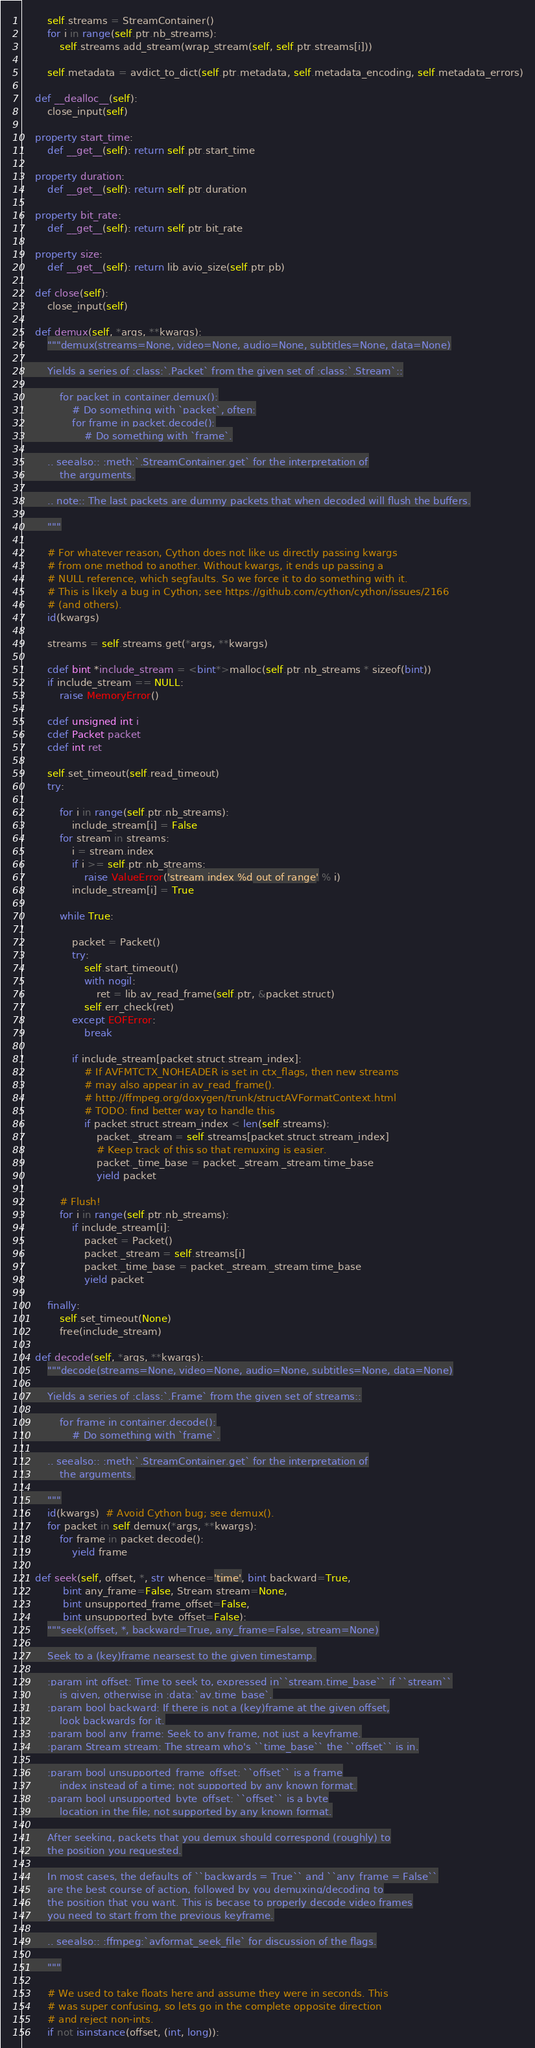Convert code to text. <code><loc_0><loc_0><loc_500><loc_500><_Cython_>        self.streams = StreamContainer()
        for i in range(self.ptr.nb_streams):
            self.streams.add_stream(wrap_stream(self, self.ptr.streams[i]))

        self.metadata = avdict_to_dict(self.ptr.metadata, self.metadata_encoding, self.metadata_errors)

    def __dealloc__(self):
        close_input(self)

    property start_time:
        def __get__(self): return self.ptr.start_time

    property duration:
        def __get__(self): return self.ptr.duration

    property bit_rate:
        def __get__(self): return self.ptr.bit_rate

    property size:
        def __get__(self): return lib.avio_size(self.ptr.pb)

    def close(self):
        close_input(self)

    def demux(self, *args, **kwargs):
        """demux(streams=None, video=None, audio=None, subtitles=None, data=None)

        Yields a series of :class:`.Packet` from the given set of :class:`.Stream`::

            for packet in container.demux():
                # Do something with `packet`, often:
                for frame in packet.decode():
                    # Do something with `frame`.

        .. seealso:: :meth:`.StreamContainer.get` for the interpretation of
            the arguments.

        .. note:: The last packets are dummy packets that when decoded will flush the buffers.

        """

        # For whatever reason, Cython does not like us directly passing kwargs
        # from one method to another. Without kwargs, it ends up passing a
        # NULL reference, which segfaults. So we force it to do something with it.
        # This is likely a bug in Cython; see https://github.com/cython/cython/issues/2166
        # (and others).
        id(kwargs)

        streams = self.streams.get(*args, **kwargs)

        cdef bint *include_stream = <bint*>malloc(self.ptr.nb_streams * sizeof(bint))
        if include_stream == NULL:
            raise MemoryError()

        cdef unsigned int i
        cdef Packet packet
        cdef int ret

        self.set_timeout(self.read_timeout)
        try:

            for i in range(self.ptr.nb_streams):
                include_stream[i] = False
            for stream in streams:
                i = stream.index
                if i >= self.ptr.nb_streams:
                    raise ValueError('stream index %d out of range' % i)
                include_stream[i] = True

            while True:

                packet = Packet()
                try:
                    self.start_timeout()
                    with nogil:
                        ret = lib.av_read_frame(self.ptr, &packet.struct)
                    self.err_check(ret)
                except EOFError:
                    break

                if include_stream[packet.struct.stream_index]:
                    # If AVFMTCTX_NOHEADER is set in ctx_flags, then new streams
                    # may also appear in av_read_frame().
                    # http://ffmpeg.org/doxygen/trunk/structAVFormatContext.html
                    # TODO: find better way to handle this
                    if packet.struct.stream_index < len(self.streams):
                        packet._stream = self.streams[packet.struct.stream_index]
                        # Keep track of this so that remuxing is easier.
                        packet._time_base = packet._stream._stream.time_base
                        yield packet

            # Flush!
            for i in range(self.ptr.nb_streams):
                if include_stream[i]:
                    packet = Packet()
                    packet._stream = self.streams[i]
                    packet._time_base = packet._stream._stream.time_base
                    yield packet

        finally:
            self.set_timeout(None)
            free(include_stream)

    def decode(self, *args, **kwargs):
        """decode(streams=None, video=None, audio=None, subtitles=None, data=None)

        Yields a series of :class:`.Frame` from the given set of streams::

            for frame in container.decode():
                # Do something with `frame`.

        .. seealso:: :meth:`.StreamContainer.get` for the interpretation of
            the arguments.

        """
        id(kwargs)  # Avoid Cython bug; see demux().
        for packet in self.demux(*args, **kwargs):
            for frame in packet.decode():
                yield frame

    def seek(self, offset, *, str whence='time', bint backward=True,
             bint any_frame=False, Stream stream=None,
             bint unsupported_frame_offset=False,
             bint unsupported_byte_offset=False):
        """seek(offset, *, backward=True, any_frame=False, stream=None)

        Seek to a (key)frame nearsest to the given timestamp.

        :param int offset: Time to seek to, expressed in``stream.time_base`` if ``stream``
            is given, otherwise in :data:`av.time_base`.
        :param bool backward: If there is not a (key)frame at the given offset,
            look backwards for it.
        :param bool any_frame: Seek to any frame, not just a keyframe.
        :param Stream stream: The stream who's ``time_base`` the ``offset`` is in.

        :param bool unsupported_frame_offset: ``offset`` is a frame
            index instead of a time; not supported by any known format.
        :param bool unsupported_byte_offset: ``offset`` is a byte
            location in the file; not supported by any known format.

        After seeking, packets that you demux should correspond (roughly) to
        the position you requested.

        In most cases, the defaults of ``backwards = True`` and ``any_frame = False``
        are the best course of action, followed by you demuxing/decoding to
        the position that you want. This is becase to properly decode video frames
        you need to start from the previous keyframe.

        .. seealso:: :ffmpeg:`avformat_seek_file` for discussion of the flags.

        """

        # We used to take floats here and assume they were in seconds. This
        # was super confusing, so lets go in the complete opposite direction
        # and reject non-ints.
        if not isinstance(offset, (int, long)):</code> 